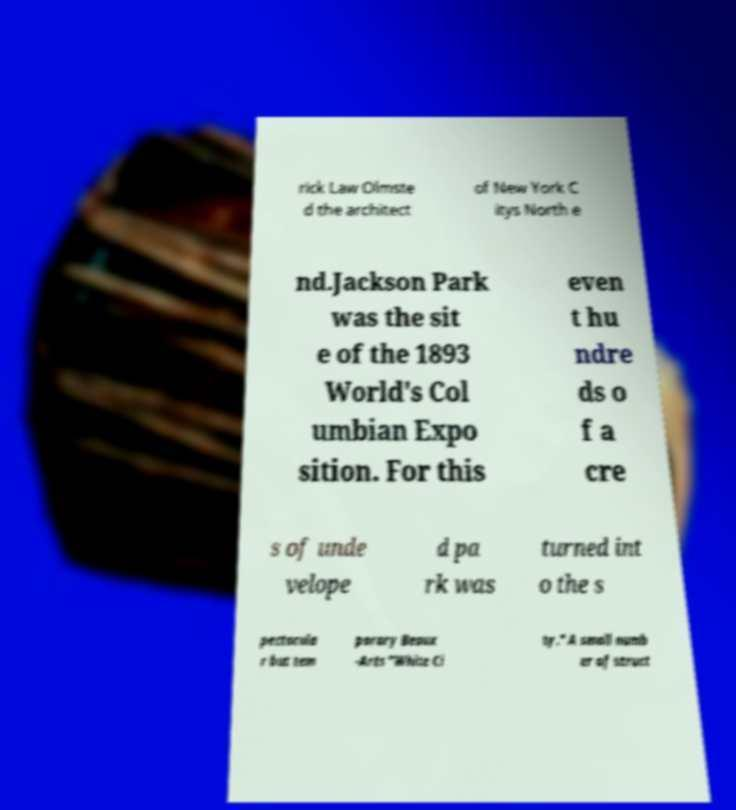For documentation purposes, I need the text within this image transcribed. Could you provide that? rick Law Olmste d the architect of New York C itys North e nd.Jackson Park was the sit e of the 1893 World's Col umbian Expo sition. For this even t hu ndre ds o f a cre s of unde velope d pa rk was turned int o the s pectacula r but tem porary Beaux -Arts "White Ci ty." A small numb er of struct 